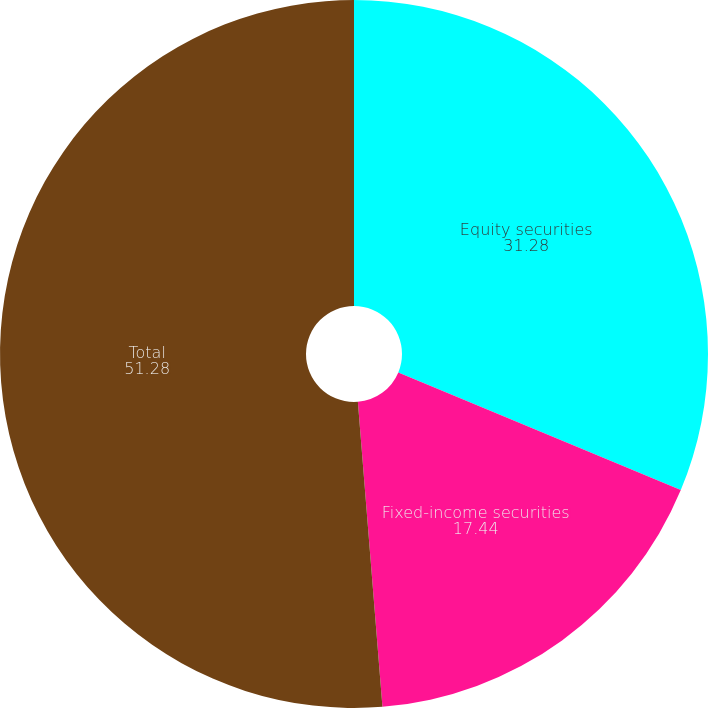Convert chart. <chart><loc_0><loc_0><loc_500><loc_500><pie_chart><fcel>Equity securities<fcel>Fixed-income securities<fcel>Total<nl><fcel>31.28%<fcel>17.44%<fcel>51.28%<nl></chart> 